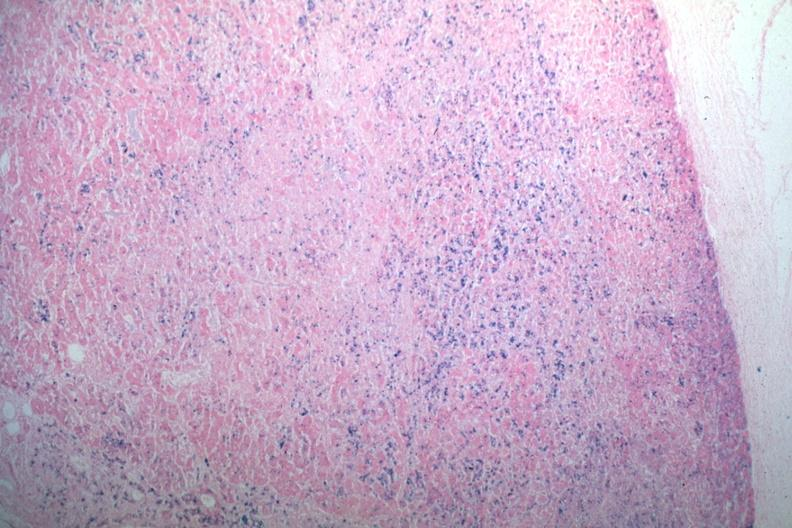s quite good liver present?
Answer the question using a single word or phrase. No 